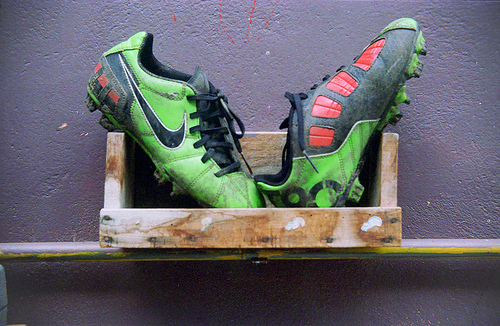<image>
Can you confirm if the box is behind the bar? No. The box is not behind the bar. From this viewpoint, the box appears to be positioned elsewhere in the scene. Is the right shoe to the right of the left shoe? No. The right shoe is not to the right of the left shoe. The horizontal positioning shows a different relationship. 